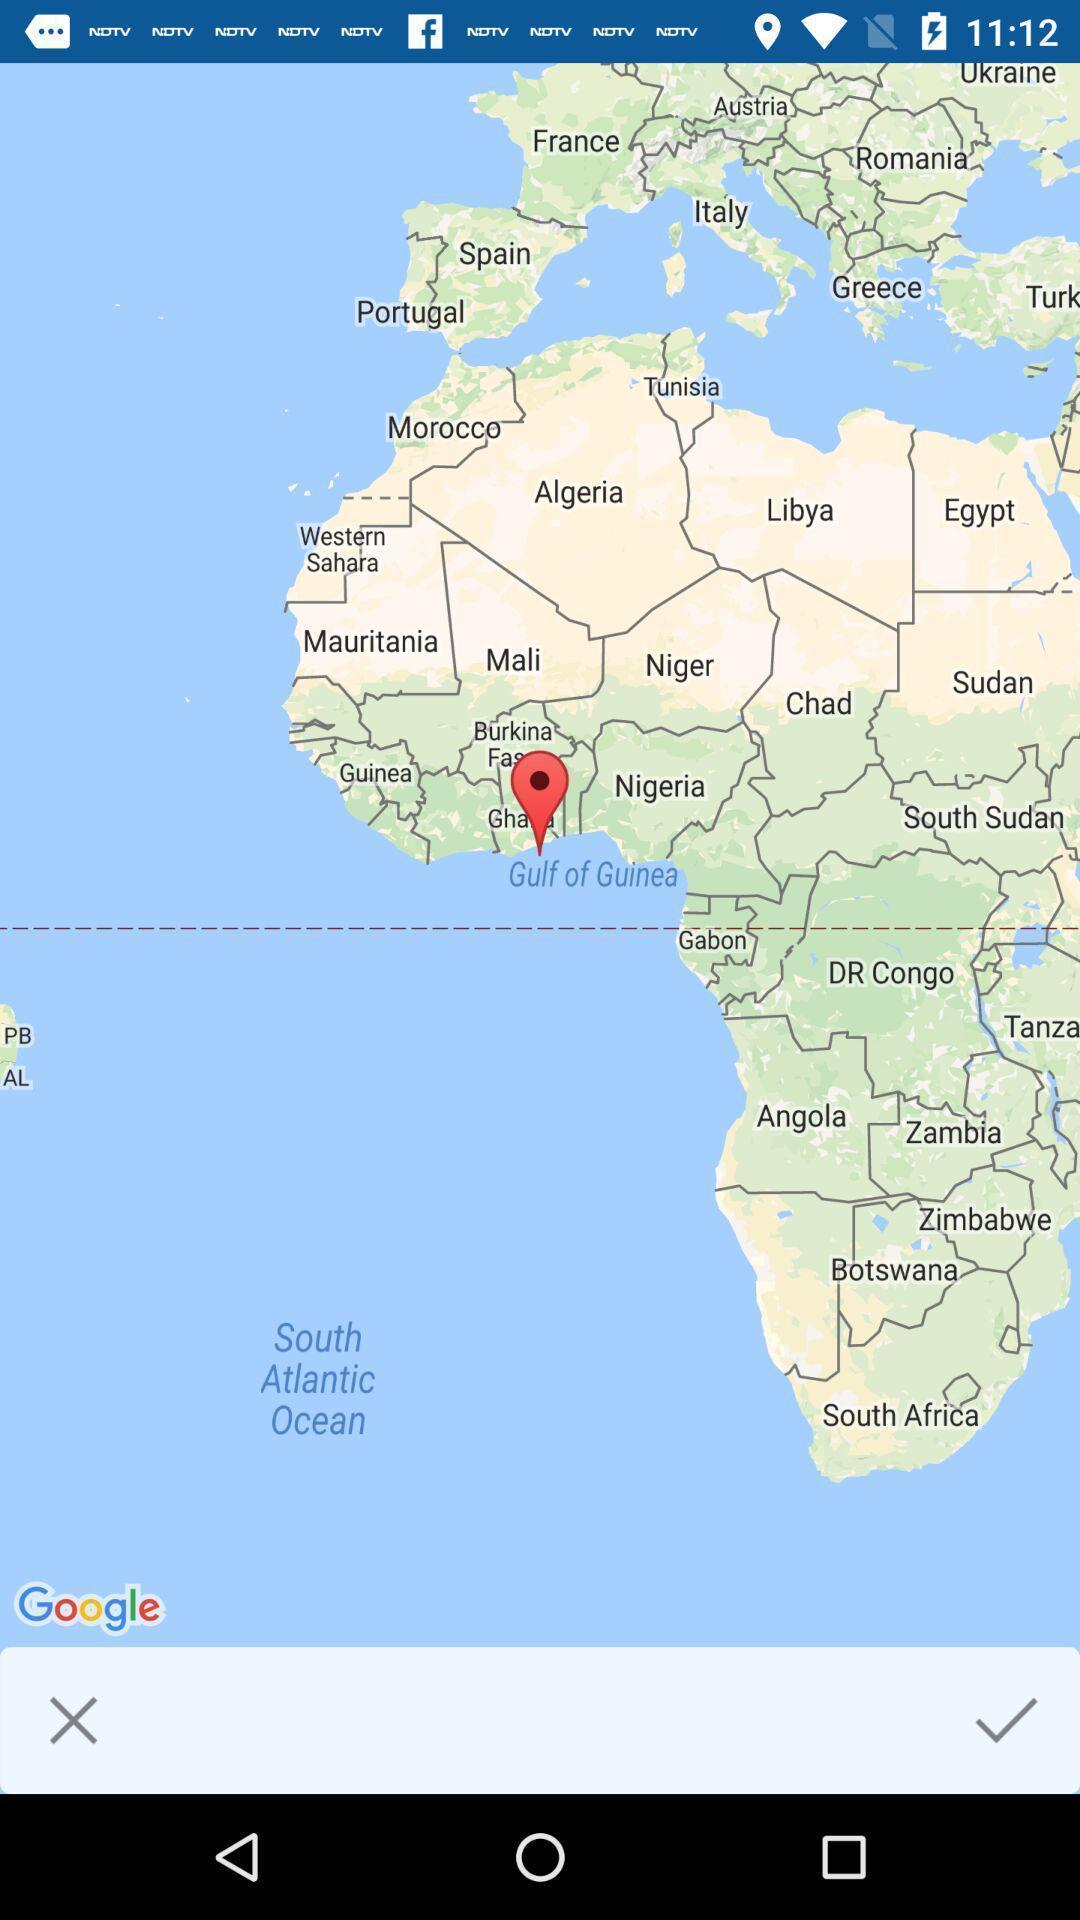Please provide a description for this image. Page showing to find route. 